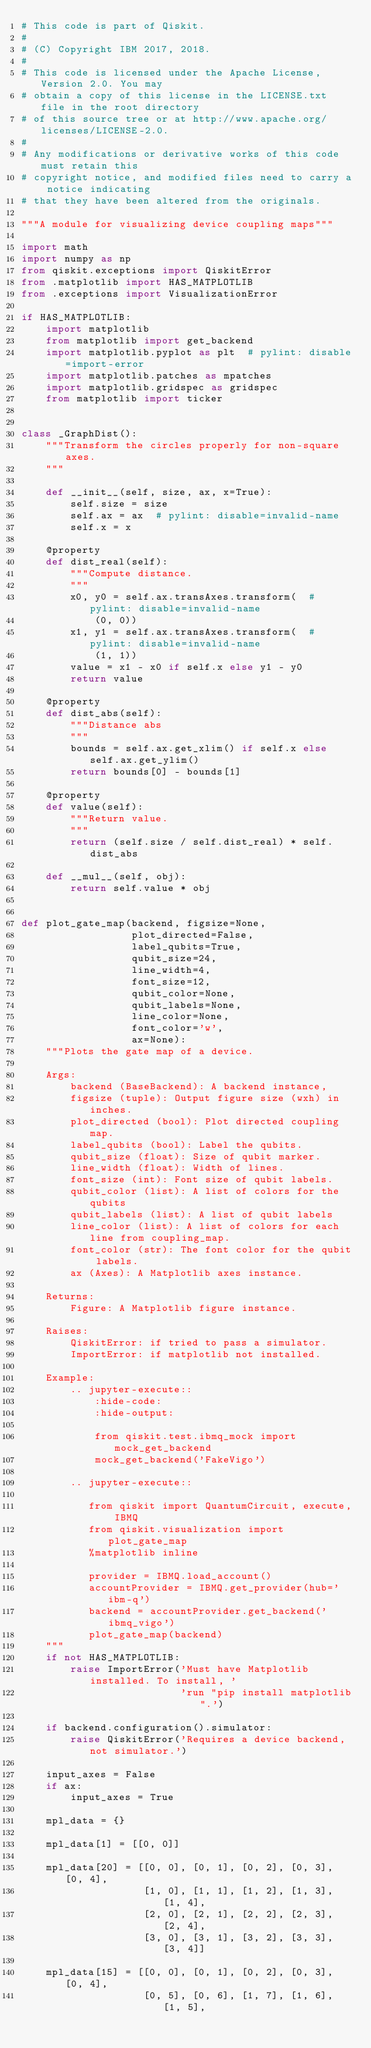Convert code to text. <code><loc_0><loc_0><loc_500><loc_500><_Python_># This code is part of Qiskit.
#
# (C) Copyright IBM 2017, 2018.
#
# This code is licensed under the Apache License, Version 2.0. You may
# obtain a copy of this license in the LICENSE.txt file in the root directory
# of this source tree or at http://www.apache.org/licenses/LICENSE-2.0.
#
# Any modifications or derivative works of this code must retain this
# copyright notice, and modified files need to carry a notice indicating
# that they have been altered from the originals.

"""A module for visualizing device coupling maps"""

import math
import numpy as np
from qiskit.exceptions import QiskitError
from .matplotlib import HAS_MATPLOTLIB
from .exceptions import VisualizationError

if HAS_MATPLOTLIB:
    import matplotlib
    from matplotlib import get_backend
    import matplotlib.pyplot as plt  # pylint: disable=import-error
    import matplotlib.patches as mpatches
    import matplotlib.gridspec as gridspec
    from matplotlib import ticker


class _GraphDist():
    """Transform the circles properly for non-square axes.
    """

    def __init__(self, size, ax, x=True):
        self.size = size
        self.ax = ax  # pylint: disable=invalid-name
        self.x = x

    @property
    def dist_real(self):
        """Compute distance.
        """
        x0, y0 = self.ax.transAxes.transform(  # pylint: disable=invalid-name
            (0, 0))
        x1, y1 = self.ax.transAxes.transform(  # pylint: disable=invalid-name
            (1, 1))
        value = x1 - x0 if self.x else y1 - y0
        return value

    @property
    def dist_abs(self):
        """Distance abs
        """
        bounds = self.ax.get_xlim() if self.x else self.ax.get_ylim()
        return bounds[0] - bounds[1]

    @property
    def value(self):
        """Return value.
        """
        return (self.size / self.dist_real) * self.dist_abs

    def __mul__(self, obj):
        return self.value * obj


def plot_gate_map(backend, figsize=None,
                  plot_directed=False,
                  label_qubits=True,
                  qubit_size=24,
                  line_width=4,
                  font_size=12,
                  qubit_color=None,
                  qubit_labels=None,
                  line_color=None,
                  font_color='w',
                  ax=None):
    """Plots the gate map of a device.

    Args:
        backend (BaseBackend): A backend instance,
        figsize (tuple): Output figure size (wxh) in inches.
        plot_directed (bool): Plot directed coupling map.
        label_qubits (bool): Label the qubits.
        qubit_size (float): Size of qubit marker.
        line_width (float): Width of lines.
        font_size (int): Font size of qubit labels.
        qubit_color (list): A list of colors for the qubits
        qubit_labels (list): A list of qubit labels
        line_color (list): A list of colors for each line from coupling_map.
        font_color (str): The font color for the qubit labels.
        ax (Axes): A Matplotlib axes instance.

    Returns:
        Figure: A Matplotlib figure instance.

    Raises:
        QiskitError: if tried to pass a simulator.
        ImportError: if matplotlib not installed.

    Example:
        .. jupyter-execute::
            :hide-code:
            :hide-output:

            from qiskit.test.ibmq_mock import mock_get_backend
            mock_get_backend('FakeVigo')

        .. jupyter-execute::

           from qiskit import QuantumCircuit, execute, IBMQ
           from qiskit.visualization import plot_gate_map
           %matplotlib inline

           provider = IBMQ.load_account()
           accountProvider = IBMQ.get_provider(hub='ibm-q')
           backend = accountProvider.get_backend('ibmq_vigo')
           plot_gate_map(backend)
    """
    if not HAS_MATPLOTLIB:
        raise ImportError('Must have Matplotlib installed. To install, '
                          'run "pip install matplotlib".')

    if backend.configuration().simulator:
        raise QiskitError('Requires a device backend, not simulator.')

    input_axes = False
    if ax:
        input_axes = True

    mpl_data = {}

    mpl_data[1] = [[0, 0]]

    mpl_data[20] = [[0, 0], [0, 1], [0, 2], [0, 3], [0, 4],
                    [1, 0], [1, 1], [1, 2], [1, 3], [1, 4],
                    [2, 0], [2, 1], [2, 2], [2, 3], [2, 4],
                    [3, 0], [3, 1], [3, 2], [3, 3], [3, 4]]

    mpl_data[15] = [[0, 0], [0, 1], [0, 2], [0, 3], [0, 4],
                    [0, 5], [0, 6], [1, 7], [1, 6], [1, 5],</code> 